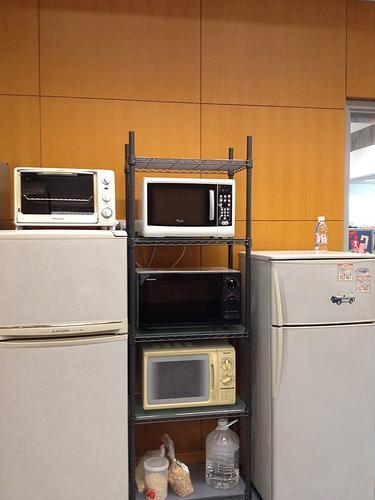How many microwaves are on the shelf?
Give a very brief answer. 3. How many refrigerators are there?
Give a very brief answer. 2. How many doors does the frig have?
Give a very brief answer. 2. 